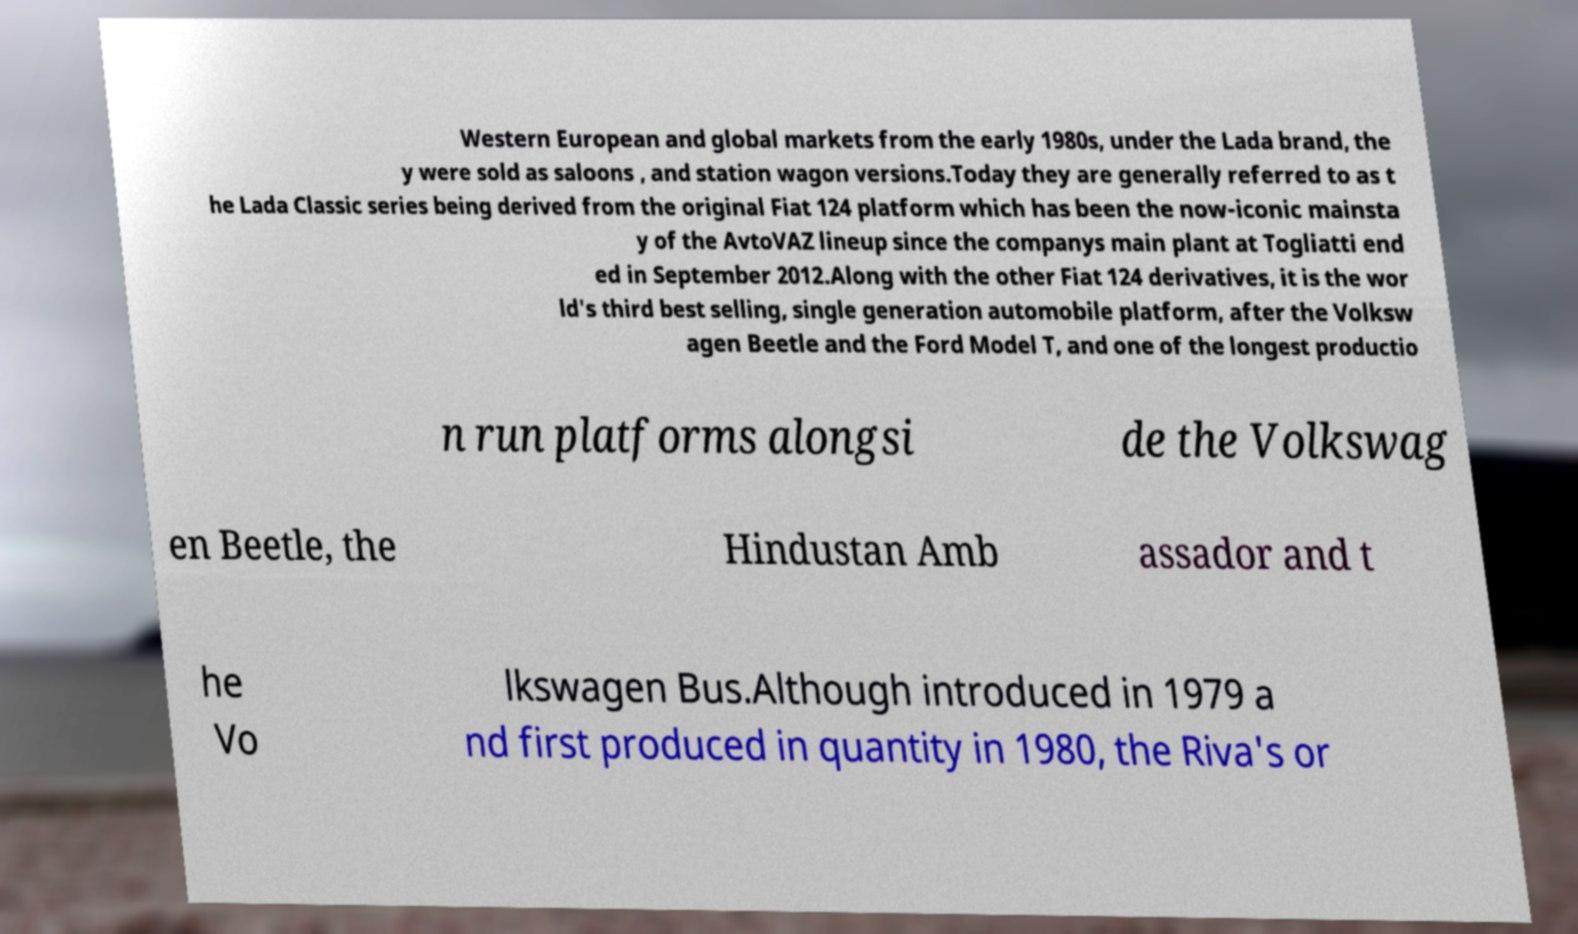Can you read and provide the text displayed in the image?This photo seems to have some interesting text. Can you extract and type it out for me? Western European and global markets from the early 1980s, under the Lada brand, the y were sold as saloons , and station wagon versions.Today they are generally referred to as t he Lada Classic series being derived from the original Fiat 124 platform which has been the now-iconic mainsta y of the AvtoVAZ lineup since the companys main plant at Togliatti end ed in September 2012.Along with the other Fiat 124 derivatives, it is the wor ld's third best selling, single generation automobile platform, after the Volksw agen Beetle and the Ford Model T, and one of the longest productio n run platforms alongsi de the Volkswag en Beetle, the Hindustan Amb assador and t he Vo lkswagen Bus.Although introduced in 1979 a nd first produced in quantity in 1980, the Riva's or 